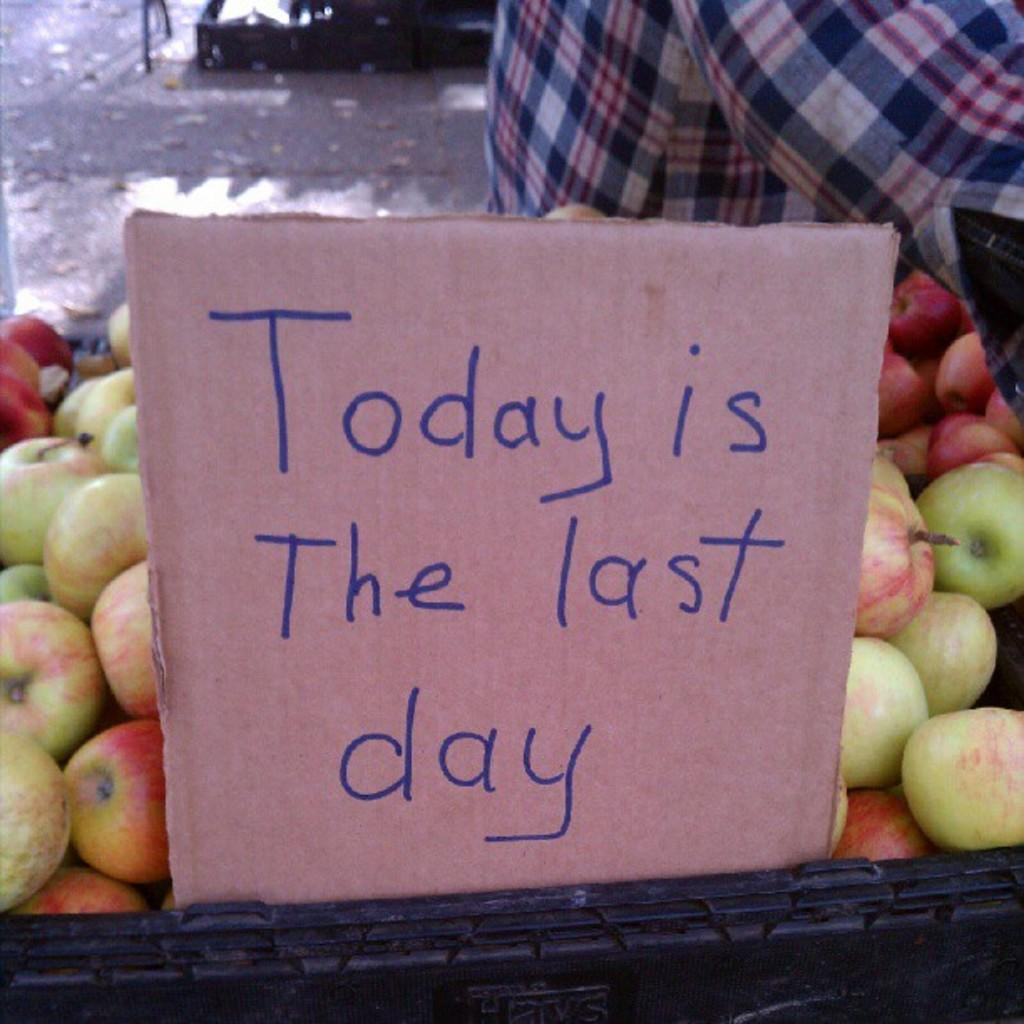What is located in the foreground of the image? There is a cardboard in the foreground of the image. What can be seen on the cardboard? Something is written on the cardboard. What does the text on the cardboard say? The text on the cardboard says "today is the last day." How loud is the quiet area in the image? There is no mention of a quiet area in the image, so it cannot be determined how loud it is. 